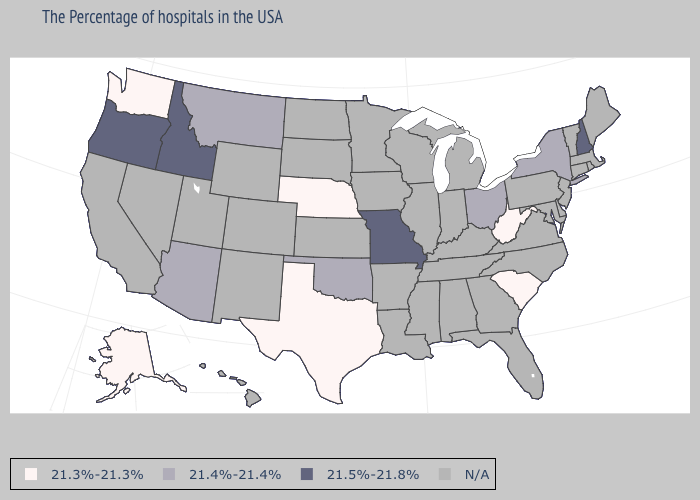Does West Virginia have the lowest value in the USA?
Write a very short answer. Yes. What is the value of Hawaii?
Give a very brief answer. N/A. Does the map have missing data?
Give a very brief answer. Yes. Does Idaho have the highest value in the USA?
Answer briefly. Yes. What is the lowest value in states that border Vermont?
Quick response, please. 21.4%-21.4%. What is the value of North Dakota?
Concise answer only. N/A. Which states hav the highest value in the West?
Keep it brief. Idaho, Oregon. Name the states that have a value in the range 21.5%-21.8%?
Write a very short answer. New Hampshire, Missouri, Idaho, Oregon. Name the states that have a value in the range 21.3%-21.3%?
Keep it brief. South Carolina, West Virginia, Nebraska, Texas, Washington, Alaska. Name the states that have a value in the range 21.5%-21.8%?
Answer briefly. New Hampshire, Missouri, Idaho, Oregon. What is the highest value in the MidWest ?
Concise answer only. 21.5%-21.8%. Does the map have missing data?
Be succinct. Yes. Does Oregon have the highest value in the USA?
Keep it brief. Yes. What is the highest value in the MidWest ?
Answer briefly. 21.5%-21.8%. 